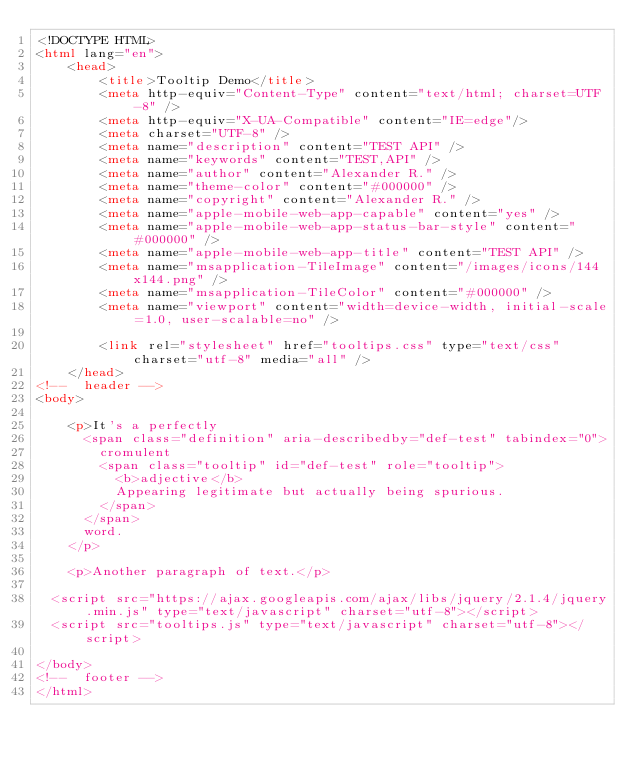<code> <loc_0><loc_0><loc_500><loc_500><_HTML_><!DOCTYPE HTML>
<html lang="en">
    <head>
        <title>Tooltip Demo</title>
        <meta http-equiv="Content-Type" content="text/html; charset=UTF-8" />
        <meta http-equiv="X-UA-Compatible" content="IE=edge"/>
        <meta charset="UTF-8" />
        <meta name="description" content="TEST API" />
        <meta name="keywords" content="TEST,API" />
        <meta name="author" content="Alexander R." />
        <meta name="theme-color" content="#000000" />
        <meta name="copyright" content="Alexander R." />
        <meta name="apple-mobile-web-app-capable" content="yes" />
        <meta name="apple-mobile-web-app-status-bar-style" content="#000000" />
        <meta name="apple-mobile-web-app-title" content="TEST API" />
        <meta name="msapplication-TileImage" content="/images/icons/144x144.png" />
        <meta name="msapplication-TileColor" content="#000000" />
        <meta name="viewport" content="width=device-width, initial-scale=1.0, user-scalable=no" />

        <link rel="stylesheet" href="tooltips.css" type="text/css" charset="utf-8" media="all" />
    </head>
<!--  header -->
<body>

    <p>It's a perfectly
      <span class="definition" aria-describedby="def-test" tabindex="0">
        cromulent
        <span class="tooltip" id="def-test" role="tooltip">
          <b>adjective</b>
          Appearing legitimate but actually being spurious.
        </span>
      </span>
      word.
    </p>

    <p>Another paragraph of text.</p>

  <script src="https://ajax.googleapis.com/ajax/libs/jquery/2.1.4/jquery.min.js" type="text/javascript" charset="utf-8"></script>
  <script src="tooltips.js" type="text/javascript" charset="utf-8"></script>

</body>
<!--  footer -->
</html>
</code> 